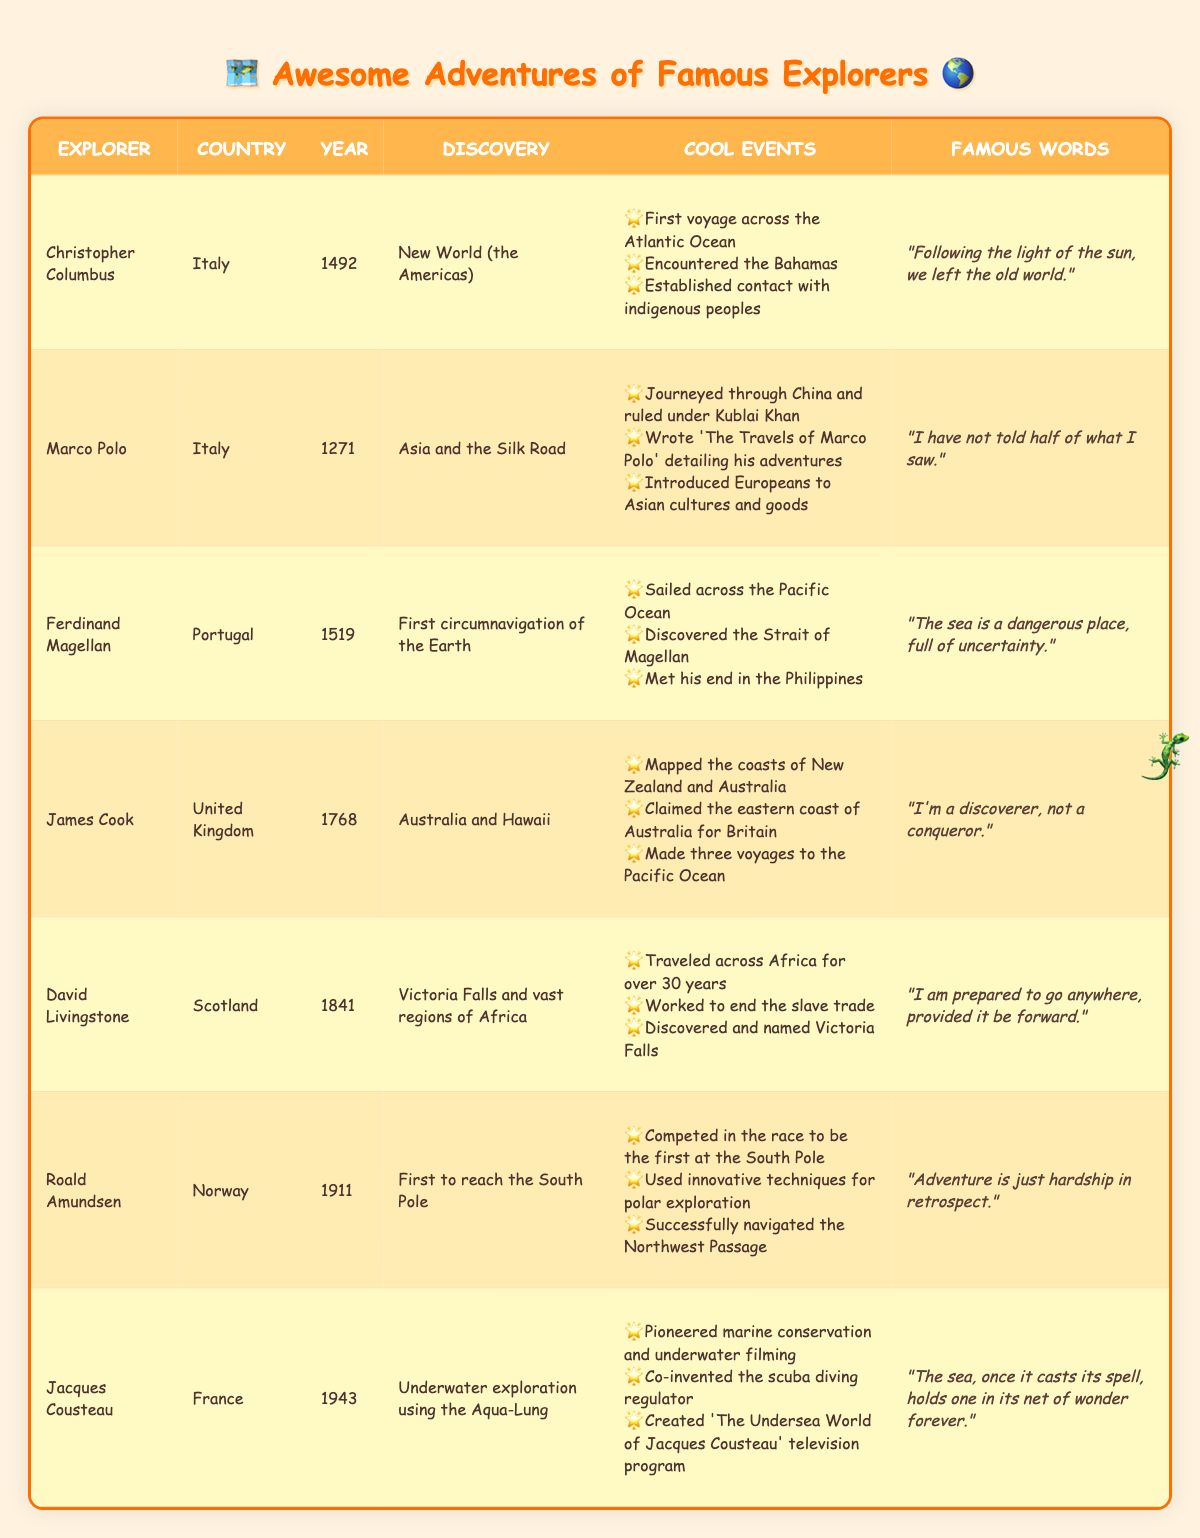What country did Marco Polo come from? Marco Polo's country of origin is listed in the table under the "Country" column. It shows "Italy" for Marco Polo.
Answer: Italy Who discovered Victoria Falls? To find out who discovered Victoria Falls, I check the "Discovery" column and find it associated with David Livingstone.
Answer: David Livingstone In what year did Christopher Columbus make his discovery? The year of discovery for Christopher Columbus is given in the "Year" column. It states 1492.
Answer: 1492 Is Jacques Cousteau known for underwater exploration? Looking in the table, Jacques Cousteau's discovery is described as "Underwater exploration using the Aqua-Lung," confirming that he is indeed known for that.
Answer: Yes Which explorer was the first to reach the South Pole? The table indicates that Roald Amundsen is listed under the discovery "First to reach the South Pole," which confirms he is the explorer known for that achievement.
Answer: Roald Amundsen How many explorers listed are from Italy? To find this, I count the explorers whose country of origin is Italy. In the table, both Christopher Columbus and Marco Polo are from Italy, totaling 2 explorers.
Answer: 2 What are the significant events associated with James Cook's explorations? I review the "Significant Events" column for James Cook. It includes three events: mapping coasts, claiming Australia's eastern coast, and making three voyages to the Pacific Ocean.
Answer: Mapped coasts, claimed eastern coast of Australia, made three voyages to Pacific Ocean Which explorer's quote emphasizes the idea of adventure? Roald Amundsen's quote states, "Adventure is just hardship in retrospect," which clearly emphasizes his view on adventure.
Answer: Roald Amundsen In which year did Ferdinand Magellan's discovery happen? The "Year" column shows the year of discovery for Ferdinand Magellan as 1519.
Answer: 1519 